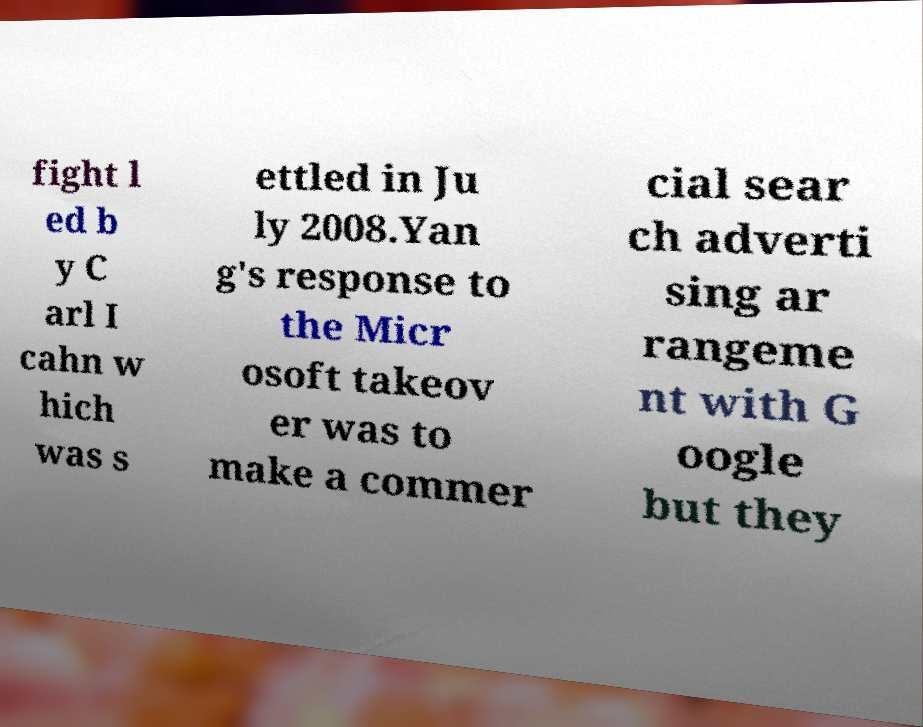There's text embedded in this image that I need extracted. Can you transcribe it verbatim? fight l ed b y C arl I cahn w hich was s ettled in Ju ly 2008.Yan g's response to the Micr osoft takeov er was to make a commer cial sear ch adverti sing ar rangeme nt with G oogle but they 